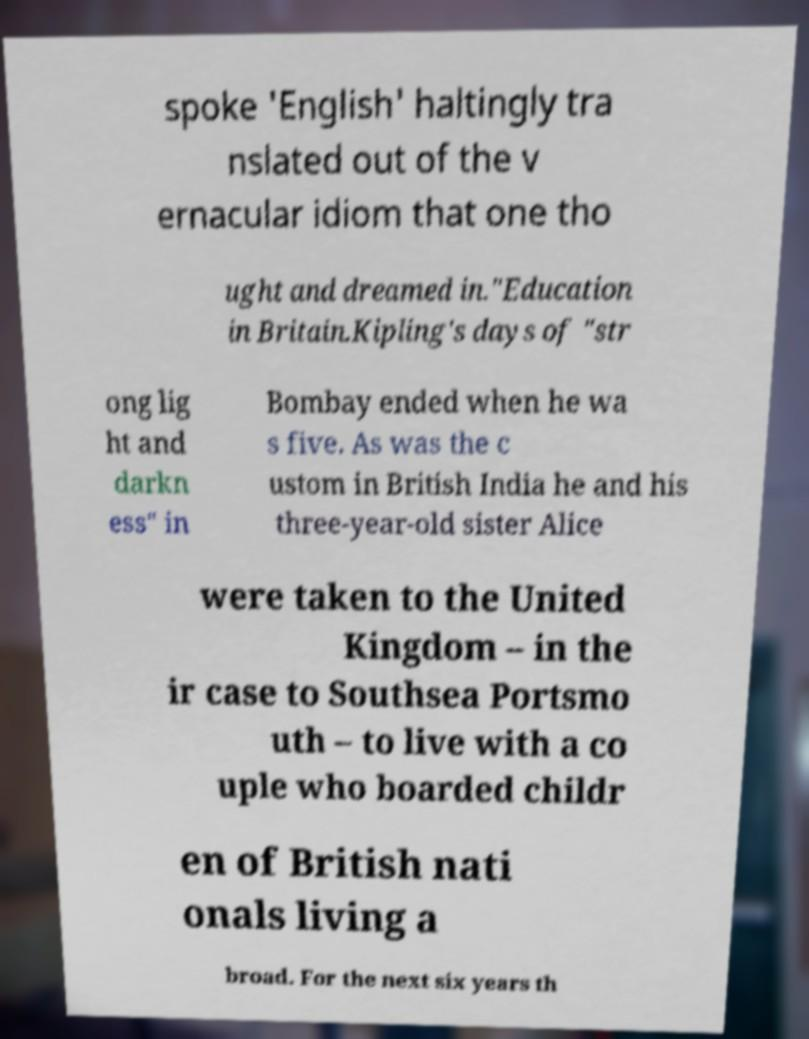Can you accurately transcribe the text from the provided image for me? spoke 'English' haltingly tra nslated out of the v ernacular idiom that one tho ught and dreamed in."Education in Britain.Kipling's days of "str ong lig ht and darkn ess" in Bombay ended when he wa s five. As was the c ustom in British India he and his three-year-old sister Alice were taken to the United Kingdom – in the ir case to Southsea Portsmo uth – to live with a co uple who boarded childr en of British nati onals living a broad. For the next six years th 